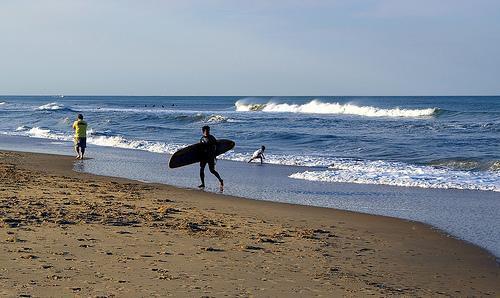How many people are visible?
Give a very brief answer. 3. How many kids in the photo?
Give a very brief answer. 1. How many kites are being flown?
Give a very brief answer. 0. 